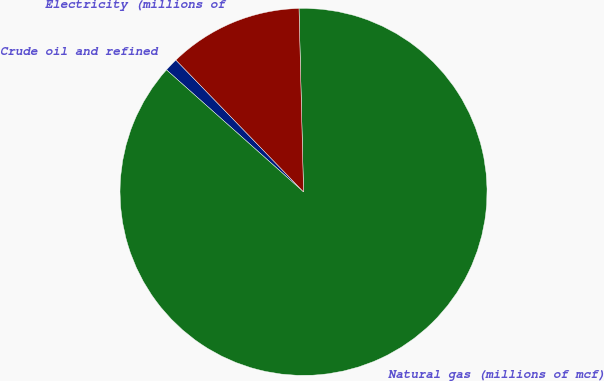Convert chart. <chart><loc_0><loc_0><loc_500><loc_500><pie_chart><fcel>Crude oil and refined<fcel>Natural gas (millions of mcf)<fcel>Electricity (millions of<nl><fcel>1.18%<fcel>86.97%<fcel>11.85%<nl></chart> 